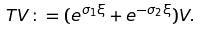Convert formula to latex. <formula><loc_0><loc_0><loc_500><loc_500>T V \colon = ( e ^ { \sigma _ { 1 } \xi } + e ^ { - \sigma _ { 2 } \xi } ) V .</formula> 